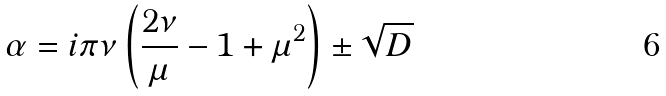<formula> <loc_0><loc_0><loc_500><loc_500>\alpha = i \pi \nu \left ( \frac { 2 \nu } { \mu } - 1 + \mu ^ { 2 } \right ) \pm \sqrt { D }</formula> 